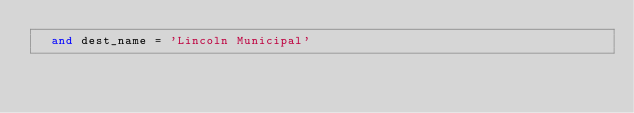<code> <loc_0><loc_0><loc_500><loc_500><_SQL_>  and dest_name = 'Lincoln Municipal'
</code> 